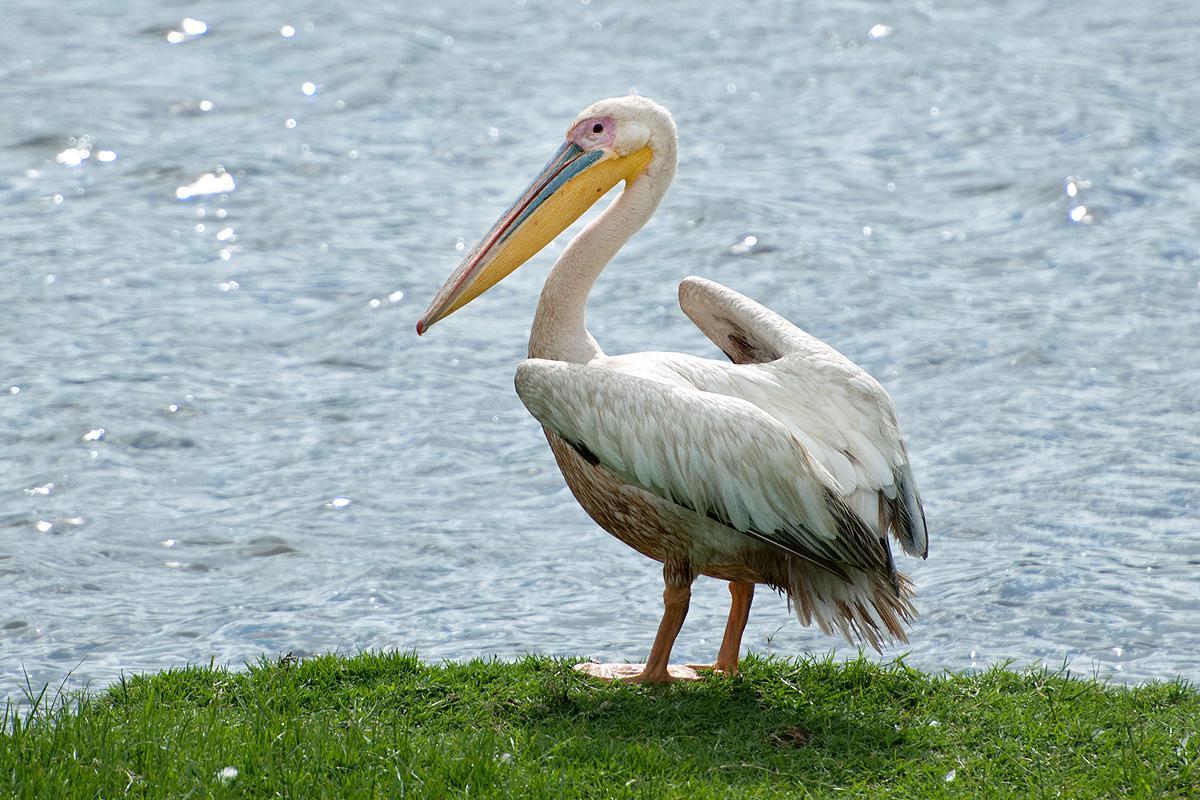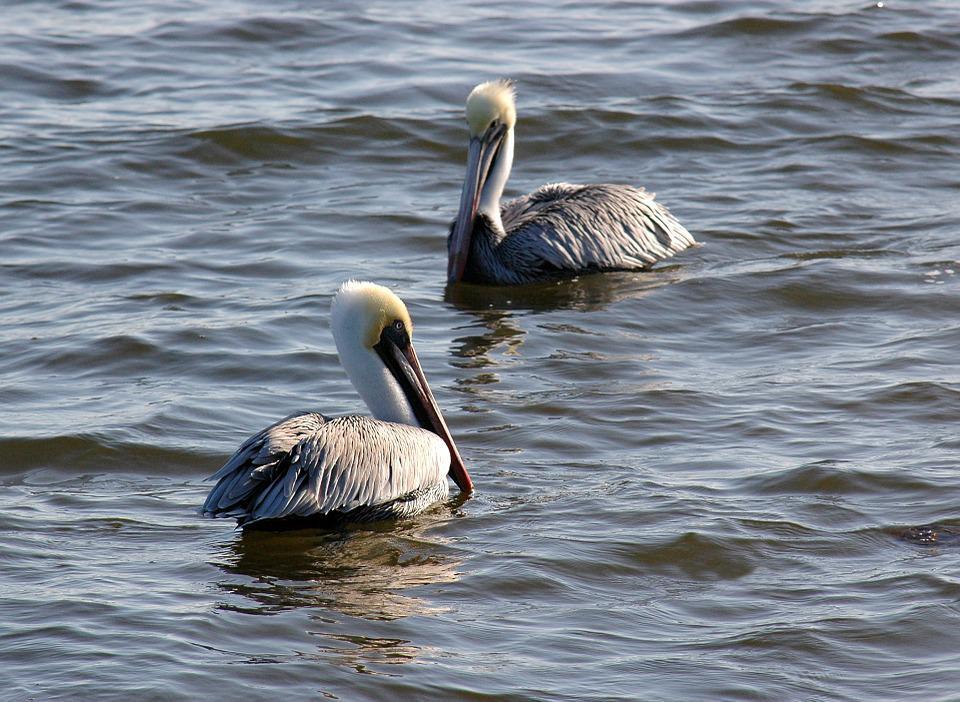The first image is the image on the left, the second image is the image on the right. Examine the images to the left and right. Is the description "There are 2 adult pelicans and 1 baby pelican in the water." accurate? Answer yes or no. No. 